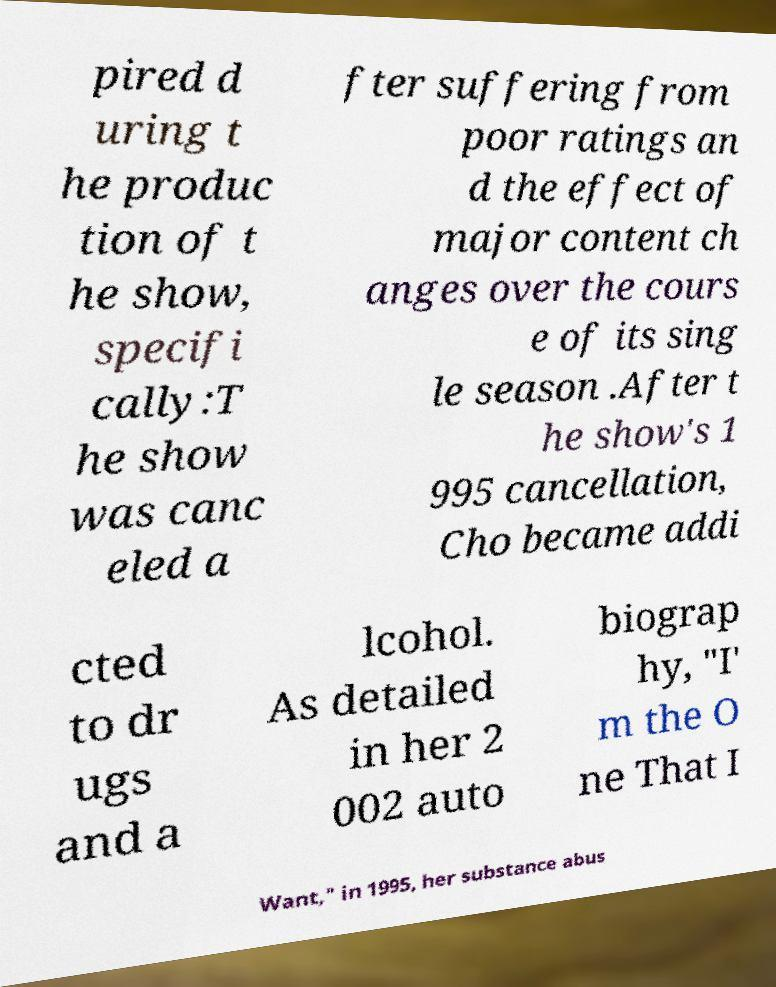Could you assist in decoding the text presented in this image and type it out clearly? pired d uring t he produc tion of t he show, specifi cally:T he show was canc eled a fter suffering from poor ratings an d the effect of major content ch anges over the cours e of its sing le season .After t he show's 1 995 cancellation, Cho became addi cted to dr ugs and a lcohol. As detailed in her 2 002 auto biograp hy, "I' m the O ne That I Want," in 1995, her substance abus 